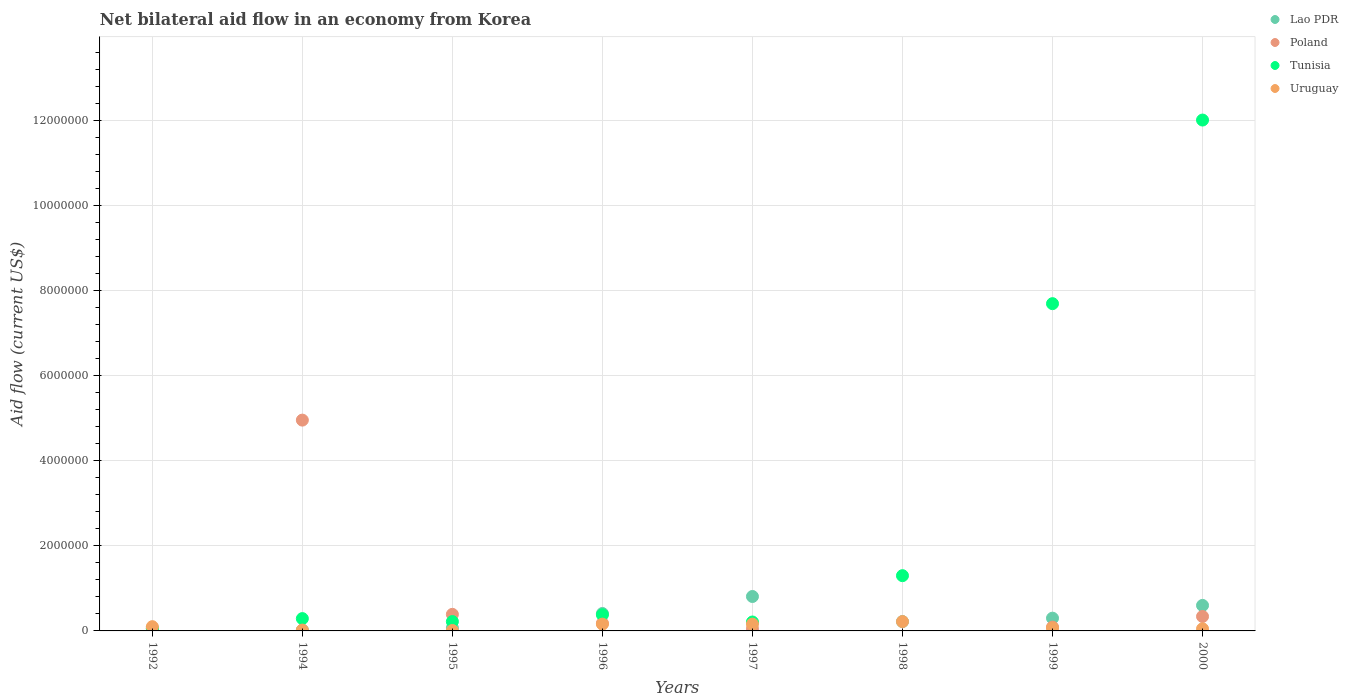Is the number of dotlines equal to the number of legend labels?
Make the answer very short. No. What is the net bilateral aid flow in Lao PDR in 1994?
Provide a short and direct response. 2.00e+04. Across all years, what is the maximum net bilateral aid flow in Tunisia?
Your response must be concise. 1.20e+07. What is the total net bilateral aid flow in Uruguay in the graph?
Give a very brief answer. 7.90e+05. What is the difference between the net bilateral aid flow in Lao PDR in 1992 and that in 1997?
Keep it short and to the point. -8.00e+05. What is the average net bilateral aid flow in Uruguay per year?
Your answer should be very brief. 9.88e+04. In the year 1997, what is the difference between the net bilateral aid flow in Tunisia and net bilateral aid flow in Uruguay?
Ensure brevity in your answer.  5.00e+04. Is the net bilateral aid flow in Lao PDR in 1992 less than that in 1996?
Your response must be concise. Yes. Is the difference between the net bilateral aid flow in Tunisia in 1995 and 1998 greater than the difference between the net bilateral aid flow in Uruguay in 1995 and 1998?
Ensure brevity in your answer.  No. What is the difference between the highest and the second highest net bilateral aid flow in Tunisia?
Offer a very short reply. 4.32e+06. In how many years, is the net bilateral aid flow in Poland greater than the average net bilateral aid flow in Poland taken over all years?
Your answer should be compact. 1. Is the sum of the net bilateral aid flow in Uruguay in 1996 and 1997 greater than the maximum net bilateral aid flow in Tunisia across all years?
Make the answer very short. No. Is it the case that in every year, the sum of the net bilateral aid flow in Uruguay and net bilateral aid flow in Tunisia  is greater than the sum of net bilateral aid flow in Lao PDR and net bilateral aid flow in Poland?
Provide a succinct answer. No. Does the net bilateral aid flow in Poland monotonically increase over the years?
Give a very brief answer. No. Does the graph contain any zero values?
Offer a very short reply. Yes. Does the graph contain grids?
Keep it short and to the point. Yes. Where does the legend appear in the graph?
Your answer should be compact. Top right. How many legend labels are there?
Ensure brevity in your answer.  4. How are the legend labels stacked?
Provide a short and direct response. Vertical. What is the title of the graph?
Provide a short and direct response. Net bilateral aid flow in an economy from Korea. Does "Israel" appear as one of the legend labels in the graph?
Your answer should be compact. No. What is the label or title of the Y-axis?
Provide a short and direct response. Aid flow (current US$). What is the Aid flow (current US$) of Lao PDR in 1992?
Ensure brevity in your answer.  10000. What is the Aid flow (current US$) in Tunisia in 1992?
Your answer should be very brief. 5.00e+04. What is the Aid flow (current US$) of Uruguay in 1992?
Offer a terse response. 1.00e+05. What is the Aid flow (current US$) of Lao PDR in 1994?
Offer a terse response. 2.00e+04. What is the Aid flow (current US$) of Poland in 1994?
Offer a terse response. 4.96e+06. What is the Aid flow (current US$) in Tunisia in 1994?
Keep it short and to the point. 2.90e+05. What is the Aid flow (current US$) of Uruguay in 1994?
Ensure brevity in your answer.  2.00e+04. What is the Aid flow (current US$) of Tunisia in 1995?
Your response must be concise. 2.20e+05. What is the Aid flow (current US$) in Uruguay in 1995?
Provide a succinct answer. 10000. What is the Aid flow (current US$) of Poland in 1996?
Offer a very short reply. 1.80e+05. What is the Aid flow (current US$) in Tunisia in 1996?
Provide a succinct answer. 3.80e+05. What is the Aid flow (current US$) of Lao PDR in 1997?
Provide a succinct answer. 8.10e+05. What is the Aid flow (current US$) of Poland in 1997?
Provide a short and direct response. 5.00e+04. What is the Aid flow (current US$) of Tunisia in 1997?
Your answer should be compact. 2.10e+05. What is the Aid flow (current US$) of Poland in 1998?
Your response must be concise. 0. What is the Aid flow (current US$) in Tunisia in 1998?
Your answer should be compact. 1.30e+06. What is the Aid flow (current US$) in Uruguay in 1998?
Your answer should be very brief. 2.20e+05. What is the Aid flow (current US$) in Lao PDR in 1999?
Offer a very short reply. 3.00e+05. What is the Aid flow (current US$) of Tunisia in 1999?
Offer a terse response. 7.70e+06. What is the Aid flow (current US$) in Lao PDR in 2000?
Offer a very short reply. 6.00e+05. What is the Aid flow (current US$) in Tunisia in 2000?
Make the answer very short. 1.20e+07. What is the Aid flow (current US$) in Uruguay in 2000?
Your response must be concise. 5.00e+04. Across all years, what is the maximum Aid flow (current US$) of Lao PDR?
Your answer should be compact. 8.10e+05. Across all years, what is the maximum Aid flow (current US$) of Poland?
Your answer should be very brief. 4.96e+06. Across all years, what is the maximum Aid flow (current US$) in Tunisia?
Your response must be concise. 1.20e+07. Across all years, what is the maximum Aid flow (current US$) in Uruguay?
Ensure brevity in your answer.  2.20e+05. Across all years, what is the minimum Aid flow (current US$) of Poland?
Ensure brevity in your answer.  0. Across all years, what is the minimum Aid flow (current US$) of Tunisia?
Your response must be concise. 5.00e+04. Across all years, what is the minimum Aid flow (current US$) of Uruguay?
Make the answer very short. 10000. What is the total Aid flow (current US$) of Lao PDR in the graph?
Ensure brevity in your answer.  2.44e+06. What is the total Aid flow (current US$) in Poland in the graph?
Ensure brevity in your answer.  6.08e+06. What is the total Aid flow (current US$) of Tunisia in the graph?
Your answer should be compact. 2.22e+07. What is the total Aid flow (current US$) of Uruguay in the graph?
Ensure brevity in your answer.  7.90e+05. What is the difference between the Aid flow (current US$) in Poland in 1992 and that in 1994?
Provide a short and direct response. -4.89e+06. What is the difference between the Aid flow (current US$) in Tunisia in 1992 and that in 1994?
Provide a succinct answer. -2.40e+05. What is the difference between the Aid flow (current US$) of Poland in 1992 and that in 1995?
Make the answer very short. -3.20e+05. What is the difference between the Aid flow (current US$) of Lao PDR in 1992 and that in 1996?
Your answer should be compact. -4.00e+05. What is the difference between the Aid flow (current US$) of Poland in 1992 and that in 1996?
Give a very brief answer. -1.10e+05. What is the difference between the Aid flow (current US$) in Tunisia in 1992 and that in 1996?
Your answer should be very brief. -3.30e+05. What is the difference between the Aid flow (current US$) in Uruguay in 1992 and that in 1996?
Make the answer very short. -6.00e+04. What is the difference between the Aid flow (current US$) of Lao PDR in 1992 and that in 1997?
Offer a terse response. -8.00e+05. What is the difference between the Aid flow (current US$) in Poland in 1992 and that in 1997?
Keep it short and to the point. 2.00e+04. What is the difference between the Aid flow (current US$) of Tunisia in 1992 and that in 1998?
Your answer should be compact. -1.25e+06. What is the difference between the Aid flow (current US$) in Lao PDR in 1992 and that in 1999?
Make the answer very short. -2.90e+05. What is the difference between the Aid flow (current US$) in Poland in 1992 and that in 1999?
Provide a succinct answer. -2.00e+04. What is the difference between the Aid flow (current US$) in Tunisia in 1992 and that in 1999?
Your answer should be compact. -7.65e+06. What is the difference between the Aid flow (current US$) in Lao PDR in 1992 and that in 2000?
Your answer should be compact. -5.90e+05. What is the difference between the Aid flow (current US$) of Poland in 1992 and that in 2000?
Ensure brevity in your answer.  -2.70e+05. What is the difference between the Aid flow (current US$) of Tunisia in 1992 and that in 2000?
Give a very brief answer. -1.20e+07. What is the difference between the Aid flow (current US$) of Poland in 1994 and that in 1995?
Provide a short and direct response. 4.57e+06. What is the difference between the Aid flow (current US$) in Tunisia in 1994 and that in 1995?
Provide a succinct answer. 7.00e+04. What is the difference between the Aid flow (current US$) in Uruguay in 1994 and that in 1995?
Offer a very short reply. 10000. What is the difference between the Aid flow (current US$) in Lao PDR in 1994 and that in 1996?
Ensure brevity in your answer.  -3.90e+05. What is the difference between the Aid flow (current US$) of Poland in 1994 and that in 1996?
Give a very brief answer. 4.78e+06. What is the difference between the Aid flow (current US$) in Tunisia in 1994 and that in 1996?
Ensure brevity in your answer.  -9.00e+04. What is the difference between the Aid flow (current US$) of Uruguay in 1994 and that in 1996?
Ensure brevity in your answer.  -1.40e+05. What is the difference between the Aid flow (current US$) of Lao PDR in 1994 and that in 1997?
Make the answer very short. -7.90e+05. What is the difference between the Aid flow (current US$) in Poland in 1994 and that in 1997?
Keep it short and to the point. 4.91e+06. What is the difference between the Aid flow (current US$) of Uruguay in 1994 and that in 1997?
Provide a succinct answer. -1.40e+05. What is the difference between the Aid flow (current US$) of Tunisia in 1994 and that in 1998?
Your answer should be very brief. -1.01e+06. What is the difference between the Aid flow (current US$) in Lao PDR in 1994 and that in 1999?
Your answer should be compact. -2.80e+05. What is the difference between the Aid flow (current US$) of Poland in 1994 and that in 1999?
Give a very brief answer. 4.87e+06. What is the difference between the Aid flow (current US$) in Tunisia in 1994 and that in 1999?
Give a very brief answer. -7.41e+06. What is the difference between the Aid flow (current US$) in Lao PDR in 1994 and that in 2000?
Keep it short and to the point. -5.80e+05. What is the difference between the Aid flow (current US$) of Poland in 1994 and that in 2000?
Provide a short and direct response. 4.62e+06. What is the difference between the Aid flow (current US$) in Tunisia in 1994 and that in 2000?
Offer a very short reply. -1.17e+07. What is the difference between the Aid flow (current US$) of Uruguay in 1994 and that in 2000?
Your answer should be very brief. -3.00e+04. What is the difference between the Aid flow (current US$) of Lao PDR in 1995 and that in 1996?
Offer a very short reply. -3.40e+05. What is the difference between the Aid flow (current US$) of Uruguay in 1995 and that in 1996?
Offer a very short reply. -1.50e+05. What is the difference between the Aid flow (current US$) of Lao PDR in 1995 and that in 1997?
Provide a short and direct response. -7.40e+05. What is the difference between the Aid flow (current US$) of Poland in 1995 and that in 1997?
Keep it short and to the point. 3.40e+05. What is the difference between the Aid flow (current US$) of Tunisia in 1995 and that in 1997?
Make the answer very short. 10000. What is the difference between the Aid flow (current US$) in Uruguay in 1995 and that in 1997?
Your answer should be compact. -1.50e+05. What is the difference between the Aid flow (current US$) in Tunisia in 1995 and that in 1998?
Provide a succinct answer. -1.08e+06. What is the difference between the Aid flow (current US$) of Uruguay in 1995 and that in 1998?
Keep it short and to the point. -2.10e+05. What is the difference between the Aid flow (current US$) of Tunisia in 1995 and that in 1999?
Provide a short and direct response. -7.48e+06. What is the difference between the Aid flow (current US$) in Uruguay in 1995 and that in 1999?
Give a very brief answer. -6.00e+04. What is the difference between the Aid flow (current US$) in Lao PDR in 1995 and that in 2000?
Make the answer very short. -5.30e+05. What is the difference between the Aid flow (current US$) in Poland in 1995 and that in 2000?
Keep it short and to the point. 5.00e+04. What is the difference between the Aid flow (current US$) of Tunisia in 1995 and that in 2000?
Ensure brevity in your answer.  -1.18e+07. What is the difference between the Aid flow (current US$) of Lao PDR in 1996 and that in 1997?
Your answer should be very brief. -4.00e+05. What is the difference between the Aid flow (current US$) in Poland in 1996 and that in 1997?
Your response must be concise. 1.30e+05. What is the difference between the Aid flow (current US$) of Uruguay in 1996 and that in 1997?
Give a very brief answer. 0. What is the difference between the Aid flow (current US$) in Lao PDR in 1996 and that in 1998?
Ensure brevity in your answer.  1.90e+05. What is the difference between the Aid flow (current US$) of Tunisia in 1996 and that in 1998?
Offer a very short reply. -9.20e+05. What is the difference between the Aid flow (current US$) of Poland in 1996 and that in 1999?
Your answer should be compact. 9.00e+04. What is the difference between the Aid flow (current US$) in Tunisia in 1996 and that in 1999?
Offer a terse response. -7.32e+06. What is the difference between the Aid flow (current US$) of Tunisia in 1996 and that in 2000?
Offer a terse response. -1.16e+07. What is the difference between the Aid flow (current US$) in Lao PDR in 1997 and that in 1998?
Your answer should be compact. 5.90e+05. What is the difference between the Aid flow (current US$) of Tunisia in 1997 and that in 1998?
Offer a terse response. -1.09e+06. What is the difference between the Aid flow (current US$) in Lao PDR in 1997 and that in 1999?
Your answer should be very brief. 5.10e+05. What is the difference between the Aid flow (current US$) of Tunisia in 1997 and that in 1999?
Your answer should be very brief. -7.49e+06. What is the difference between the Aid flow (current US$) in Uruguay in 1997 and that in 1999?
Give a very brief answer. 9.00e+04. What is the difference between the Aid flow (current US$) of Poland in 1997 and that in 2000?
Your response must be concise. -2.90e+05. What is the difference between the Aid flow (current US$) in Tunisia in 1997 and that in 2000?
Make the answer very short. -1.18e+07. What is the difference between the Aid flow (current US$) of Uruguay in 1997 and that in 2000?
Keep it short and to the point. 1.10e+05. What is the difference between the Aid flow (current US$) of Lao PDR in 1998 and that in 1999?
Keep it short and to the point. -8.00e+04. What is the difference between the Aid flow (current US$) of Tunisia in 1998 and that in 1999?
Make the answer very short. -6.40e+06. What is the difference between the Aid flow (current US$) in Lao PDR in 1998 and that in 2000?
Your answer should be compact. -3.80e+05. What is the difference between the Aid flow (current US$) in Tunisia in 1998 and that in 2000?
Provide a short and direct response. -1.07e+07. What is the difference between the Aid flow (current US$) in Lao PDR in 1999 and that in 2000?
Offer a terse response. -3.00e+05. What is the difference between the Aid flow (current US$) in Tunisia in 1999 and that in 2000?
Keep it short and to the point. -4.32e+06. What is the difference between the Aid flow (current US$) in Lao PDR in 1992 and the Aid flow (current US$) in Poland in 1994?
Your answer should be very brief. -4.95e+06. What is the difference between the Aid flow (current US$) of Lao PDR in 1992 and the Aid flow (current US$) of Tunisia in 1994?
Give a very brief answer. -2.80e+05. What is the difference between the Aid flow (current US$) of Poland in 1992 and the Aid flow (current US$) of Tunisia in 1994?
Ensure brevity in your answer.  -2.20e+05. What is the difference between the Aid flow (current US$) in Tunisia in 1992 and the Aid flow (current US$) in Uruguay in 1994?
Your answer should be very brief. 3.00e+04. What is the difference between the Aid flow (current US$) of Lao PDR in 1992 and the Aid flow (current US$) of Poland in 1995?
Offer a very short reply. -3.80e+05. What is the difference between the Aid flow (current US$) in Lao PDR in 1992 and the Aid flow (current US$) in Poland in 1996?
Ensure brevity in your answer.  -1.70e+05. What is the difference between the Aid flow (current US$) of Lao PDR in 1992 and the Aid flow (current US$) of Tunisia in 1996?
Offer a very short reply. -3.70e+05. What is the difference between the Aid flow (current US$) of Poland in 1992 and the Aid flow (current US$) of Tunisia in 1996?
Offer a terse response. -3.10e+05. What is the difference between the Aid flow (current US$) of Tunisia in 1992 and the Aid flow (current US$) of Uruguay in 1996?
Provide a succinct answer. -1.10e+05. What is the difference between the Aid flow (current US$) of Lao PDR in 1992 and the Aid flow (current US$) of Poland in 1997?
Keep it short and to the point. -4.00e+04. What is the difference between the Aid flow (current US$) of Lao PDR in 1992 and the Aid flow (current US$) of Tunisia in 1997?
Make the answer very short. -2.00e+05. What is the difference between the Aid flow (current US$) in Poland in 1992 and the Aid flow (current US$) in Tunisia in 1997?
Provide a short and direct response. -1.40e+05. What is the difference between the Aid flow (current US$) of Tunisia in 1992 and the Aid flow (current US$) of Uruguay in 1997?
Your answer should be very brief. -1.10e+05. What is the difference between the Aid flow (current US$) in Lao PDR in 1992 and the Aid flow (current US$) in Tunisia in 1998?
Keep it short and to the point. -1.29e+06. What is the difference between the Aid flow (current US$) in Lao PDR in 1992 and the Aid flow (current US$) in Uruguay in 1998?
Your answer should be compact. -2.10e+05. What is the difference between the Aid flow (current US$) in Poland in 1992 and the Aid flow (current US$) in Tunisia in 1998?
Your answer should be compact. -1.23e+06. What is the difference between the Aid flow (current US$) in Poland in 1992 and the Aid flow (current US$) in Uruguay in 1998?
Provide a short and direct response. -1.50e+05. What is the difference between the Aid flow (current US$) in Tunisia in 1992 and the Aid flow (current US$) in Uruguay in 1998?
Offer a terse response. -1.70e+05. What is the difference between the Aid flow (current US$) of Lao PDR in 1992 and the Aid flow (current US$) of Tunisia in 1999?
Provide a short and direct response. -7.69e+06. What is the difference between the Aid flow (current US$) in Poland in 1992 and the Aid flow (current US$) in Tunisia in 1999?
Your response must be concise. -7.63e+06. What is the difference between the Aid flow (current US$) in Lao PDR in 1992 and the Aid flow (current US$) in Poland in 2000?
Keep it short and to the point. -3.30e+05. What is the difference between the Aid flow (current US$) of Lao PDR in 1992 and the Aid flow (current US$) of Tunisia in 2000?
Provide a short and direct response. -1.20e+07. What is the difference between the Aid flow (current US$) of Lao PDR in 1992 and the Aid flow (current US$) of Uruguay in 2000?
Keep it short and to the point. -4.00e+04. What is the difference between the Aid flow (current US$) in Poland in 1992 and the Aid flow (current US$) in Tunisia in 2000?
Offer a very short reply. -1.20e+07. What is the difference between the Aid flow (current US$) in Poland in 1992 and the Aid flow (current US$) in Uruguay in 2000?
Provide a short and direct response. 2.00e+04. What is the difference between the Aid flow (current US$) of Lao PDR in 1994 and the Aid flow (current US$) of Poland in 1995?
Your response must be concise. -3.70e+05. What is the difference between the Aid flow (current US$) of Poland in 1994 and the Aid flow (current US$) of Tunisia in 1995?
Give a very brief answer. 4.74e+06. What is the difference between the Aid flow (current US$) in Poland in 1994 and the Aid flow (current US$) in Uruguay in 1995?
Your answer should be compact. 4.95e+06. What is the difference between the Aid flow (current US$) of Tunisia in 1994 and the Aid flow (current US$) of Uruguay in 1995?
Make the answer very short. 2.80e+05. What is the difference between the Aid flow (current US$) in Lao PDR in 1994 and the Aid flow (current US$) in Tunisia in 1996?
Ensure brevity in your answer.  -3.60e+05. What is the difference between the Aid flow (current US$) in Lao PDR in 1994 and the Aid flow (current US$) in Uruguay in 1996?
Your answer should be compact. -1.40e+05. What is the difference between the Aid flow (current US$) in Poland in 1994 and the Aid flow (current US$) in Tunisia in 1996?
Make the answer very short. 4.58e+06. What is the difference between the Aid flow (current US$) in Poland in 1994 and the Aid flow (current US$) in Uruguay in 1996?
Your answer should be compact. 4.80e+06. What is the difference between the Aid flow (current US$) of Tunisia in 1994 and the Aid flow (current US$) of Uruguay in 1996?
Your response must be concise. 1.30e+05. What is the difference between the Aid flow (current US$) in Lao PDR in 1994 and the Aid flow (current US$) in Poland in 1997?
Your answer should be compact. -3.00e+04. What is the difference between the Aid flow (current US$) of Lao PDR in 1994 and the Aid flow (current US$) of Tunisia in 1997?
Your answer should be very brief. -1.90e+05. What is the difference between the Aid flow (current US$) in Lao PDR in 1994 and the Aid flow (current US$) in Uruguay in 1997?
Your response must be concise. -1.40e+05. What is the difference between the Aid flow (current US$) of Poland in 1994 and the Aid flow (current US$) of Tunisia in 1997?
Your response must be concise. 4.75e+06. What is the difference between the Aid flow (current US$) in Poland in 1994 and the Aid flow (current US$) in Uruguay in 1997?
Give a very brief answer. 4.80e+06. What is the difference between the Aid flow (current US$) of Lao PDR in 1994 and the Aid flow (current US$) of Tunisia in 1998?
Offer a terse response. -1.28e+06. What is the difference between the Aid flow (current US$) in Lao PDR in 1994 and the Aid flow (current US$) in Uruguay in 1998?
Your answer should be compact. -2.00e+05. What is the difference between the Aid flow (current US$) of Poland in 1994 and the Aid flow (current US$) of Tunisia in 1998?
Ensure brevity in your answer.  3.66e+06. What is the difference between the Aid flow (current US$) in Poland in 1994 and the Aid flow (current US$) in Uruguay in 1998?
Your answer should be compact. 4.74e+06. What is the difference between the Aid flow (current US$) of Lao PDR in 1994 and the Aid flow (current US$) of Poland in 1999?
Ensure brevity in your answer.  -7.00e+04. What is the difference between the Aid flow (current US$) in Lao PDR in 1994 and the Aid flow (current US$) in Tunisia in 1999?
Your answer should be very brief. -7.68e+06. What is the difference between the Aid flow (current US$) of Lao PDR in 1994 and the Aid flow (current US$) of Uruguay in 1999?
Keep it short and to the point. -5.00e+04. What is the difference between the Aid flow (current US$) in Poland in 1994 and the Aid flow (current US$) in Tunisia in 1999?
Give a very brief answer. -2.74e+06. What is the difference between the Aid flow (current US$) of Poland in 1994 and the Aid flow (current US$) of Uruguay in 1999?
Offer a very short reply. 4.89e+06. What is the difference between the Aid flow (current US$) in Lao PDR in 1994 and the Aid flow (current US$) in Poland in 2000?
Give a very brief answer. -3.20e+05. What is the difference between the Aid flow (current US$) in Lao PDR in 1994 and the Aid flow (current US$) in Tunisia in 2000?
Your answer should be very brief. -1.20e+07. What is the difference between the Aid flow (current US$) of Lao PDR in 1994 and the Aid flow (current US$) of Uruguay in 2000?
Your answer should be compact. -3.00e+04. What is the difference between the Aid flow (current US$) of Poland in 1994 and the Aid flow (current US$) of Tunisia in 2000?
Your answer should be very brief. -7.06e+06. What is the difference between the Aid flow (current US$) of Poland in 1994 and the Aid flow (current US$) of Uruguay in 2000?
Your answer should be very brief. 4.91e+06. What is the difference between the Aid flow (current US$) in Tunisia in 1994 and the Aid flow (current US$) in Uruguay in 2000?
Offer a very short reply. 2.40e+05. What is the difference between the Aid flow (current US$) of Lao PDR in 1995 and the Aid flow (current US$) of Tunisia in 1996?
Provide a short and direct response. -3.10e+05. What is the difference between the Aid flow (current US$) of Lao PDR in 1995 and the Aid flow (current US$) of Uruguay in 1996?
Give a very brief answer. -9.00e+04. What is the difference between the Aid flow (current US$) in Poland in 1995 and the Aid flow (current US$) in Uruguay in 1996?
Your answer should be very brief. 2.30e+05. What is the difference between the Aid flow (current US$) in Tunisia in 1995 and the Aid flow (current US$) in Uruguay in 1996?
Give a very brief answer. 6.00e+04. What is the difference between the Aid flow (current US$) of Poland in 1995 and the Aid flow (current US$) of Tunisia in 1997?
Provide a succinct answer. 1.80e+05. What is the difference between the Aid flow (current US$) in Lao PDR in 1995 and the Aid flow (current US$) in Tunisia in 1998?
Make the answer very short. -1.23e+06. What is the difference between the Aid flow (current US$) of Poland in 1995 and the Aid flow (current US$) of Tunisia in 1998?
Your response must be concise. -9.10e+05. What is the difference between the Aid flow (current US$) in Poland in 1995 and the Aid flow (current US$) in Uruguay in 1998?
Give a very brief answer. 1.70e+05. What is the difference between the Aid flow (current US$) in Tunisia in 1995 and the Aid flow (current US$) in Uruguay in 1998?
Provide a succinct answer. 0. What is the difference between the Aid flow (current US$) of Lao PDR in 1995 and the Aid flow (current US$) of Tunisia in 1999?
Offer a terse response. -7.63e+06. What is the difference between the Aid flow (current US$) of Lao PDR in 1995 and the Aid flow (current US$) of Uruguay in 1999?
Keep it short and to the point. 0. What is the difference between the Aid flow (current US$) in Poland in 1995 and the Aid flow (current US$) in Tunisia in 1999?
Provide a succinct answer. -7.31e+06. What is the difference between the Aid flow (current US$) in Poland in 1995 and the Aid flow (current US$) in Uruguay in 1999?
Your response must be concise. 3.20e+05. What is the difference between the Aid flow (current US$) of Tunisia in 1995 and the Aid flow (current US$) of Uruguay in 1999?
Make the answer very short. 1.50e+05. What is the difference between the Aid flow (current US$) of Lao PDR in 1995 and the Aid flow (current US$) of Poland in 2000?
Offer a terse response. -2.70e+05. What is the difference between the Aid flow (current US$) of Lao PDR in 1995 and the Aid flow (current US$) of Tunisia in 2000?
Make the answer very short. -1.20e+07. What is the difference between the Aid flow (current US$) in Poland in 1995 and the Aid flow (current US$) in Tunisia in 2000?
Keep it short and to the point. -1.16e+07. What is the difference between the Aid flow (current US$) of Poland in 1995 and the Aid flow (current US$) of Uruguay in 2000?
Ensure brevity in your answer.  3.40e+05. What is the difference between the Aid flow (current US$) in Tunisia in 1995 and the Aid flow (current US$) in Uruguay in 2000?
Keep it short and to the point. 1.70e+05. What is the difference between the Aid flow (current US$) in Lao PDR in 1996 and the Aid flow (current US$) in Tunisia in 1997?
Give a very brief answer. 2.00e+05. What is the difference between the Aid flow (current US$) of Lao PDR in 1996 and the Aid flow (current US$) of Uruguay in 1997?
Your response must be concise. 2.50e+05. What is the difference between the Aid flow (current US$) in Poland in 1996 and the Aid flow (current US$) in Uruguay in 1997?
Provide a succinct answer. 2.00e+04. What is the difference between the Aid flow (current US$) in Lao PDR in 1996 and the Aid flow (current US$) in Tunisia in 1998?
Your answer should be very brief. -8.90e+05. What is the difference between the Aid flow (current US$) of Poland in 1996 and the Aid flow (current US$) of Tunisia in 1998?
Your response must be concise. -1.12e+06. What is the difference between the Aid flow (current US$) of Poland in 1996 and the Aid flow (current US$) of Uruguay in 1998?
Your answer should be compact. -4.00e+04. What is the difference between the Aid flow (current US$) of Tunisia in 1996 and the Aid flow (current US$) of Uruguay in 1998?
Ensure brevity in your answer.  1.60e+05. What is the difference between the Aid flow (current US$) of Lao PDR in 1996 and the Aid flow (current US$) of Poland in 1999?
Provide a short and direct response. 3.20e+05. What is the difference between the Aid flow (current US$) in Lao PDR in 1996 and the Aid flow (current US$) in Tunisia in 1999?
Offer a very short reply. -7.29e+06. What is the difference between the Aid flow (current US$) in Poland in 1996 and the Aid flow (current US$) in Tunisia in 1999?
Offer a very short reply. -7.52e+06. What is the difference between the Aid flow (current US$) of Poland in 1996 and the Aid flow (current US$) of Uruguay in 1999?
Provide a short and direct response. 1.10e+05. What is the difference between the Aid flow (current US$) of Lao PDR in 1996 and the Aid flow (current US$) of Tunisia in 2000?
Offer a very short reply. -1.16e+07. What is the difference between the Aid flow (current US$) in Lao PDR in 1996 and the Aid flow (current US$) in Uruguay in 2000?
Ensure brevity in your answer.  3.60e+05. What is the difference between the Aid flow (current US$) of Poland in 1996 and the Aid flow (current US$) of Tunisia in 2000?
Provide a succinct answer. -1.18e+07. What is the difference between the Aid flow (current US$) in Lao PDR in 1997 and the Aid flow (current US$) in Tunisia in 1998?
Ensure brevity in your answer.  -4.90e+05. What is the difference between the Aid flow (current US$) in Lao PDR in 1997 and the Aid flow (current US$) in Uruguay in 1998?
Ensure brevity in your answer.  5.90e+05. What is the difference between the Aid flow (current US$) in Poland in 1997 and the Aid flow (current US$) in Tunisia in 1998?
Make the answer very short. -1.25e+06. What is the difference between the Aid flow (current US$) of Tunisia in 1997 and the Aid flow (current US$) of Uruguay in 1998?
Make the answer very short. -10000. What is the difference between the Aid flow (current US$) of Lao PDR in 1997 and the Aid flow (current US$) of Poland in 1999?
Give a very brief answer. 7.20e+05. What is the difference between the Aid flow (current US$) in Lao PDR in 1997 and the Aid flow (current US$) in Tunisia in 1999?
Offer a very short reply. -6.89e+06. What is the difference between the Aid flow (current US$) in Lao PDR in 1997 and the Aid flow (current US$) in Uruguay in 1999?
Keep it short and to the point. 7.40e+05. What is the difference between the Aid flow (current US$) of Poland in 1997 and the Aid flow (current US$) of Tunisia in 1999?
Ensure brevity in your answer.  -7.65e+06. What is the difference between the Aid flow (current US$) of Poland in 1997 and the Aid flow (current US$) of Uruguay in 1999?
Keep it short and to the point. -2.00e+04. What is the difference between the Aid flow (current US$) in Lao PDR in 1997 and the Aid flow (current US$) in Poland in 2000?
Make the answer very short. 4.70e+05. What is the difference between the Aid flow (current US$) in Lao PDR in 1997 and the Aid flow (current US$) in Tunisia in 2000?
Provide a succinct answer. -1.12e+07. What is the difference between the Aid flow (current US$) in Lao PDR in 1997 and the Aid flow (current US$) in Uruguay in 2000?
Provide a succinct answer. 7.60e+05. What is the difference between the Aid flow (current US$) of Poland in 1997 and the Aid flow (current US$) of Tunisia in 2000?
Ensure brevity in your answer.  -1.20e+07. What is the difference between the Aid flow (current US$) of Tunisia in 1997 and the Aid flow (current US$) of Uruguay in 2000?
Your response must be concise. 1.60e+05. What is the difference between the Aid flow (current US$) of Lao PDR in 1998 and the Aid flow (current US$) of Tunisia in 1999?
Offer a terse response. -7.48e+06. What is the difference between the Aid flow (current US$) of Lao PDR in 1998 and the Aid flow (current US$) of Uruguay in 1999?
Offer a very short reply. 1.50e+05. What is the difference between the Aid flow (current US$) of Tunisia in 1998 and the Aid flow (current US$) of Uruguay in 1999?
Your answer should be compact. 1.23e+06. What is the difference between the Aid flow (current US$) of Lao PDR in 1998 and the Aid flow (current US$) of Tunisia in 2000?
Offer a very short reply. -1.18e+07. What is the difference between the Aid flow (current US$) in Lao PDR in 1998 and the Aid flow (current US$) in Uruguay in 2000?
Your answer should be compact. 1.70e+05. What is the difference between the Aid flow (current US$) in Tunisia in 1998 and the Aid flow (current US$) in Uruguay in 2000?
Your response must be concise. 1.25e+06. What is the difference between the Aid flow (current US$) in Lao PDR in 1999 and the Aid flow (current US$) in Tunisia in 2000?
Give a very brief answer. -1.17e+07. What is the difference between the Aid flow (current US$) of Poland in 1999 and the Aid flow (current US$) of Tunisia in 2000?
Offer a terse response. -1.19e+07. What is the difference between the Aid flow (current US$) of Poland in 1999 and the Aid flow (current US$) of Uruguay in 2000?
Give a very brief answer. 4.00e+04. What is the difference between the Aid flow (current US$) of Tunisia in 1999 and the Aid flow (current US$) of Uruguay in 2000?
Offer a very short reply. 7.65e+06. What is the average Aid flow (current US$) of Lao PDR per year?
Offer a terse response. 3.05e+05. What is the average Aid flow (current US$) in Poland per year?
Offer a very short reply. 7.60e+05. What is the average Aid flow (current US$) of Tunisia per year?
Offer a very short reply. 2.77e+06. What is the average Aid flow (current US$) of Uruguay per year?
Your answer should be compact. 9.88e+04. In the year 1992, what is the difference between the Aid flow (current US$) in Lao PDR and Aid flow (current US$) in Tunisia?
Your response must be concise. -4.00e+04. In the year 1992, what is the difference between the Aid flow (current US$) of Lao PDR and Aid flow (current US$) of Uruguay?
Offer a very short reply. -9.00e+04. In the year 1992, what is the difference between the Aid flow (current US$) of Poland and Aid flow (current US$) of Uruguay?
Provide a short and direct response. -3.00e+04. In the year 1992, what is the difference between the Aid flow (current US$) in Tunisia and Aid flow (current US$) in Uruguay?
Keep it short and to the point. -5.00e+04. In the year 1994, what is the difference between the Aid flow (current US$) of Lao PDR and Aid flow (current US$) of Poland?
Ensure brevity in your answer.  -4.94e+06. In the year 1994, what is the difference between the Aid flow (current US$) of Lao PDR and Aid flow (current US$) of Uruguay?
Ensure brevity in your answer.  0. In the year 1994, what is the difference between the Aid flow (current US$) in Poland and Aid flow (current US$) in Tunisia?
Ensure brevity in your answer.  4.67e+06. In the year 1994, what is the difference between the Aid flow (current US$) in Poland and Aid flow (current US$) in Uruguay?
Keep it short and to the point. 4.94e+06. In the year 1994, what is the difference between the Aid flow (current US$) of Tunisia and Aid flow (current US$) of Uruguay?
Give a very brief answer. 2.70e+05. In the year 1995, what is the difference between the Aid flow (current US$) in Lao PDR and Aid flow (current US$) in Poland?
Your answer should be very brief. -3.20e+05. In the year 1995, what is the difference between the Aid flow (current US$) in Lao PDR and Aid flow (current US$) in Tunisia?
Provide a succinct answer. -1.50e+05. In the year 1995, what is the difference between the Aid flow (current US$) in Lao PDR and Aid flow (current US$) in Uruguay?
Offer a very short reply. 6.00e+04. In the year 1995, what is the difference between the Aid flow (current US$) of Poland and Aid flow (current US$) of Uruguay?
Offer a terse response. 3.80e+05. In the year 1995, what is the difference between the Aid flow (current US$) in Tunisia and Aid flow (current US$) in Uruguay?
Offer a terse response. 2.10e+05. In the year 1996, what is the difference between the Aid flow (current US$) of Poland and Aid flow (current US$) of Uruguay?
Your answer should be very brief. 2.00e+04. In the year 1996, what is the difference between the Aid flow (current US$) in Tunisia and Aid flow (current US$) in Uruguay?
Offer a very short reply. 2.20e+05. In the year 1997, what is the difference between the Aid flow (current US$) of Lao PDR and Aid flow (current US$) of Poland?
Your answer should be compact. 7.60e+05. In the year 1997, what is the difference between the Aid flow (current US$) in Lao PDR and Aid flow (current US$) in Tunisia?
Provide a short and direct response. 6.00e+05. In the year 1997, what is the difference between the Aid flow (current US$) in Lao PDR and Aid flow (current US$) in Uruguay?
Your answer should be compact. 6.50e+05. In the year 1997, what is the difference between the Aid flow (current US$) in Poland and Aid flow (current US$) in Tunisia?
Provide a short and direct response. -1.60e+05. In the year 1997, what is the difference between the Aid flow (current US$) of Tunisia and Aid flow (current US$) of Uruguay?
Give a very brief answer. 5.00e+04. In the year 1998, what is the difference between the Aid flow (current US$) of Lao PDR and Aid flow (current US$) of Tunisia?
Ensure brevity in your answer.  -1.08e+06. In the year 1998, what is the difference between the Aid flow (current US$) in Lao PDR and Aid flow (current US$) in Uruguay?
Keep it short and to the point. 0. In the year 1998, what is the difference between the Aid flow (current US$) of Tunisia and Aid flow (current US$) of Uruguay?
Make the answer very short. 1.08e+06. In the year 1999, what is the difference between the Aid flow (current US$) of Lao PDR and Aid flow (current US$) of Tunisia?
Ensure brevity in your answer.  -7.40e+06. In the year 1999, what is the difference between the Aid flow (current US$) in Poland and Aid flow (current US$) in Tunisia?
Your response must be concise. -7.61e+06. In the year 1999, what is the difference between the Aid flow (current US$) of Tunisia and Aid flow (current US$) of Uruguay?
Your answer should be compact. 7.63e+06. In the year 2000, what is the difference between the Aid flow (current US$) in Lao PDR and Aid flow (current US$) in Poland?
Ensure brevity in your answer.  2.60e+05. In the year 2000, what is the difference between the Aid flow (current US$) in Lao PDR and Aid flow (current US$) in Tunisia?
Provide a succinct answer. -1.14e+07. In the year 2000, what is the difference between the Aid flow (current US$) in Lao PDR and Aid flow (current US$) in Uruguay?
Offer a very short reply. 5.50e+05. In the year 2000, what is the difference between the Aid flow (current US$) of Poland and Aid flow (current US$) of Tunisia?
Give a very brief answer. -1.17e+07. In the year 2000, what is the difference between the Aid flow (current US$) in Poland and Aid flow (current US$) in Uruguay?
Provide a short and direct response. 2.90e+05. In the year 2000, what is the difference between the Aid flow (current US$) of Tunisia and Aid flow (current US$) of Uruguay?
Ensure brevity in your answer.  1.20e+07. What is the ratio of the Aid flow (current US$) of Poland in 1992 to that in 1994?
Offer a terse response. 0.01. What is the ratio of the Aid flow (current US$) in Tunisia in 1992 to that in 1994?
Offer a terse response. 0.17. What is the ratio of the Aid flow (current US$) of Uruguay in 1992 to that in 1994?
Provide a short and direct response. 5. What is the ratio of the Aid flow (current US$) in Lao PDR in 1992 to that in 1995?
Offer a terse response. 0.14. What is the ratio of the Aid flow (current US$) in Poland in 1992 to that in 1995?
Your response must be concise. 0.18. What is the ratio of the Aid flow (current US$) in Tunisia in 1992 to that in 1995?
Offer a terse response. 0.23. What is the ratio of the Aid flow (current US$) in Lao PDR in 1992 to that in 1996?
Keep it short and to the point. 0.02. What is the ratio of the Aid flow (current US$) in Poland in 1992 to that in 1996?
Your answer should be very brief. 0.39. What is the ratio of the Aid flow (current US$) of Tunisia in 1992 to that in 1996?
Your response must be concise. 0.13. What is the ratio of the Aid flow (current US$) of Lao PDR in 1992 to that in 1997?
Your response must be concise. 0.01. What is the ratio of the Aid flow (current US$) in Poland in 1992 to that in 1997?
Offer a very short reply. 1.4. What is the ratio of the Aid flow (current US$) of Tunisia in 1992 to that in 1997?
Give a very brief answer. 0.24. What is the ratio of the Aid flow (current US$) of Uruguay in 1992 to that in 1997?
Offer a very short reply. 0.62. What is the ratio of the Aid flow (current US$) in Lao PDR in 1992 to that in 1998?
Provide a short and direct response. 0.05. What is the ratio of the Aid flow (current US$) of Tunisia in 1992 to that in 1998?
Your response must be concise. 0.04. What is the ratio of the Aid flow (current US$) in Uruguay in 1992 to that in 1998?
Your answer should be compact. 0.45. What is the ratio of the Aid flow (current US$) of Lao PDR in 1992 to that in 1999?
Offer a very short reply. 0.03. What is the ratio of the Aid flow (current US$) in Tunisia in 1992 to that in 1999?
Ensure brevity in your answer.  0.01. What is the ratio of the Aid flow (current US$) of Uruguay in 1992 to that in 1999?
Your answer should be very brief. 1.43. What is the ratio of the Aid flow (current US$) of Lao PDR in 1992 to that in 2000?
Provide a succinct answer. 0.02. What is the ratio of the Aid flow (current US$) in Poland in 1992 to that in 2000?
Offer a terse response. 0.21. What is the ratio of the Aid flow (current US$) in Tunisia in 1992 to that in 2000?
Offer a terse response. 0. What is the ratio of the Aid flow (current US$) in Uruguay in 1992 to that in 2000?
Make the answer very short. 2. What is the ratio of the Aid flow (current US$) in Lao PDR in 1994 to that in 1995?
Ensure brevity in your answer.  0.29. What is the ratio of the Aid flow (current US$) in Poland in 1994 to that in 1995?
Provide a succinct answer. 12.72. What is the ratio of the Aid flow (current US$) in Tunisia in 1994 to that in 1995?
Your answer should be very brief. 1.32. What is the ratio of the Aid flow (current US$) in Lao PDR in 1994 to that in 1996?
Your response must be concise. 0.05. What is the ratio of the Aid flow (current US$) in Poland in 1994 to that in 1996?
Give a very brief answer. 27.56. What is the ratio of the Aid flow (current US$) of Tunisia in 1994 to that in 1996?
Offer a very short reply. 0.76. What is the ratio of the Aid flow (current US$) in Uruguay in 1994 to that in 1996?
Your answer should be compact. 0.12. What is the ratio of the Aid flow (current US$) of Lao PDR in 1994 to that in 1997?
Offer a very short reply. 0.02. What is the ratio of the Aid flow (current US$) of Poland in 1994 to that in 1997?
Provide a succinct answer. 99.2. What is the ratio of the Aid flow (current US$) in Tunisia in 1994 to that in 1997?
Ensure brevity in your answer.  1.38. What is the ratio of the Aid flow (current US$) of Lao PDR in 1994 to that in 1998?
Make the answer very short. 0.09. What is the ratio of the Aid flow (current US$) in Tunisia in 1994 to that in 1998?
Provide a short and direct response. 0.22. What is the ratio of the Aid flow (current US$) in Uruguay in 1994 to that in 1998?
Your answer should be very brief. 0.09. What is the ratio of the Aid flow (current US$) of Lao PDR in 1994 to that in 1999?
Offer a very short reply. 0.07. What is the ratio of the Aid flow (current US$) in Poland in 1994 to that in 1999?
Make the answer very short. 55.11. What is the ratio of the Aid flow (current US$) in Tunisia in 1994 to that in 1999?
Your response must be concise. 0.04. What is the ratio of the Aid flow (current US$) of Uruguay in 1994 to that in 1999?
Your answer should be very brief. 0.29. What is the ratio of the Aid flow (current US$) in Poland in 1994 to that in 2000?
Give a very brief answer. 14.59. What is the ratio of the Aid flow (current US$) of Tunisia in 1994 to that in 2000?
Make the answer very short. 0.02. What is the ratio of the Aid flow (current US$) of Uruguay in 1994 to that in 2000?
Your response must be concise. 0.4. What is the ratio of the Aid flow (current US$) of Lao PDR in 1995 to that in 1996?
Ensure brevity in your answer.  0.17. What is the ratio of the Aid flow (current US$) of Poland in 1995 to that in 1996?
Your response must be concise. 2.17. What is the ratio of the Aid flow (current US$) in Tunisia in 1995 to that in 1996?
Make the answer very short. 0.58. What is the ratio of the Aid flow (current US$) of Uruguay in 1995 to that in 1996?
Offer a terse response. 0.06. What is the ratio of the Aid flow (current US$) in Lao PDR in 1995 to that in 1997?
Offer a very short reply. 0.09. What is the ratio of the Aid flow (current US$) of Tunisia in 1995 to that in 1997?
Your response must be concise. 1.05. What is the ratio of the Aid flow (current US$) of Uruguay in 1995 to that in 1997?
Provide a succinct answer. 0.06. What is the ratio of the Aid flow (current US$) in Lao PDR in 1995 to that in 1998?
Your response must be concise. 0.32. What is the ratio of the Aid flow (current US$) in Tunisia in 1995 to that in 1998?
Your answer should be compact. 0.17. What is the ratio of the Aid flow (current US$) in Uruguay in 1995 to that in 1998?
Keep it short and to the point. 0.05. What is the ratio of the Aid flow (current US$) in Lao PDR in 1995 to that in 1999?
Your answer should be very brief. 0.23. What is the ratio of the Aid flow (current US$) of Poland in 1995 to that in 1999?
Ensure brevity in your answer.  4.33. What is the ratio of the Aid flow (current US$) in Tunisia in 1995 to that in 1999?
Offer a terse response. 0.03. What is the ratio of the Aid flow (current US$) of Uruguay in 1995 to that in 1999?
Provide a short and direct response. 0.14. What is the ratio of the Aid flow (current US$) of Lao PDR in 1995 to that in 2000?
Make the answer very short. 0.12. What is the ratio of the Aid flow (current US$) of Poland in 1995 to that in 2000?
Provide a short and direct response. 1.15. What is the ratio of the Aid flow (current US$) of Tunisia in 1995 to that in 2000?
Ensure brevity in your answer.  0.02. What is the ratio of the Aid flow (current US$) of Uruguay in 1995 to that in 2000?
Give a very brief answer. 0.2. What is the ratio of the Aid flow (current US$) of Lao PDR in 1996 to that in 1997?
Keep it short and to the point. 0.51. What is the ratio of the Aid flow (current US$) of Poland in 1996 to that in 1997?
Your answer should be very brief. 3.6. What is the ratio of the Aid flow (current US$) in Tunisia in 1996 to that in 1997?
Ensure brevity in your answer.  1.81. What is the ratio of the Aid flow (current US$) of Lao PDR in 1996 to that in 1998?
Offer a terse response. 1.86. What is the ratio of the Aid flow (current US$) in Tunisia in 1996 to that in 1998?
Your response must be concise. 0.29. What is the ratio of the Aid flow (current US$) of Uruguay in 1996 to that in 1998?
Your answer should be very brief. 0.73. What is the ratio of the Aid flow (current US$) of Lao PDR in 1996 to that in 1999?
Keep it short and to the point. 1.37. What is the ratio of the Aid flow (current US$) of Tunisia in 1996 to that in 1999?
Offer a terse response. 0.05. What is the ratio of the Aid flow (current US$) of Uruguay in 1996 to that in 1999?
Your answer should be very brief. 2.29. What is the ratio of the Aid flow (current US$) of Lao PDR in 1996 to that in 2000?
Your answer should be compact. 0.68. What is the ratio of the Aid flow (current US$) of Poland in 1996 to that in 2000?
Give a very brief answer. 0.53. What is the ratio of the Aid flow (current US$) in Tunisia in 1996 to that in 2000?
Provide a succinct answer. 0.03. What is the ratio of the Aid flow (current US$) of Lao PDR in 1997 to that in 1998?
Keep it short and to the point. 3.68. What is the ratio of the Aid flow (current US$) in Tunisia in 1997 to that in 1998?
Your response must be concise. 0.16. What is the ratio of the Aid flow (current US$) of Uruguay in 1997 to that in 1998?
Provide a short and direct response. 0.73. What is the ratio of the Aid flow (current US$) of Lao PDR in 1997 to that in 1999?
Keep it short and to the point. 2.7. What is the ratio of the Aid flow (current US$) in Poland in 1997 to that in 1999?
Keep it short and to the point. 0.56. What is the ratio of the Aid flow (current US$) in Tunisia in 1997 to that in 1999?
Provide a succinct answer. 0.03. What is the ratio of the Aid flow (current US$) of Uruguay in 1997 to that in 1999?
Provide a short and direct response. 2.29. What is the ratio of the Aid flow (current US$) of Lao PDR in 1997 to that in 2000?
Offer a very short reply. 1.35. What is the ratio of the Aid flow (current US$) of Poland in 1997 to that in 2000?
Offer a terse response. 0.15. What is the ratio of the Aid flow (current US$) in Tunisia in 1997 to that in 2000?
Give a very brief answer. 0.02. What is the ratio of the Aid flow (current US$) in Uruguay in 1997 to that in 2000?
Give a very brief answer. 3.2. What is the ratio of the Aid flow (current US$) of Lao PDR in 1998 to that in 1999?
Your answer should be compact. 0.73. What is the ratio of the Aid flow (current US$) in Tunisia in 1998 to that in 1999?
Make the answer very short. 0.17. What is the ratio of the Aid flow (current US$) of Uruguay in 1998 to that in 1999?
Make the answer very short. 3.14. What is the ratio of the Aid flow (current US$) in Lao PDR in 1998 to that in 2000?
Ensure brevity in your answer.  0.37. What is the ratio of the Aid flow (current US$) in Tunisia in 1998 to that in 2000?
Offer a terse response. 0.11. What is the ratio of the Aid flow (current US$) of Uruguay in 1998 to that in 2000?
Keep it short and to the point. 4.4. What is the ratio of the Aid flow (current US$) of Poland in 1999 to that in 2000?
Give a very brief answer. 0.26. What is the ratio of the Aid flow (current US$) of Tunisia in 1999 to that in 2000?
Give a very brief answer. 0.64. What is the ratio of the Aid flow (current US$) of Uruguay in 1999 to that in 2000?
Provide a succinct answer. 1.4. What is the difference between the highest and the second highest Aid flow (current US$) of Poland?
Ensure brevity in your answer.  4.57e+06. What is the difference between the highest and the second highest Aid flow (current US$) of Tunisia?
Provide a short and direct response. 4.32e+06. What is the difference between the highest and the lowest Aid flow (current US$) of Lao PDR?
Your answer should be very brief. 8.00e+05. What is the difference between the highest and the lowest Aid flow (current US$) in Poland?
Give a very brief answer. 4.96e+06. What is the difference between the highest and the lowest Aid flow (current US$) in Tunisia?
Provide a short and direct response. 1.20e+07. What is the difference between the highest and the lowest Aid flow (current US$) in Uruguay?
Provide a short and direct response. 2.10e+05. 